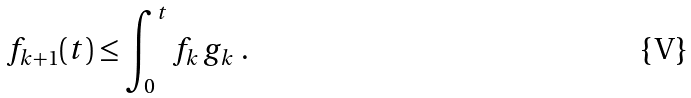<formula> <loc_0><loc_0><loc_500><loc_500>f _ { k + 1 } ( t ) \leq \int _ { 0 } ^ { t } f _ { k } \, g _ { k } \ .</formula> 